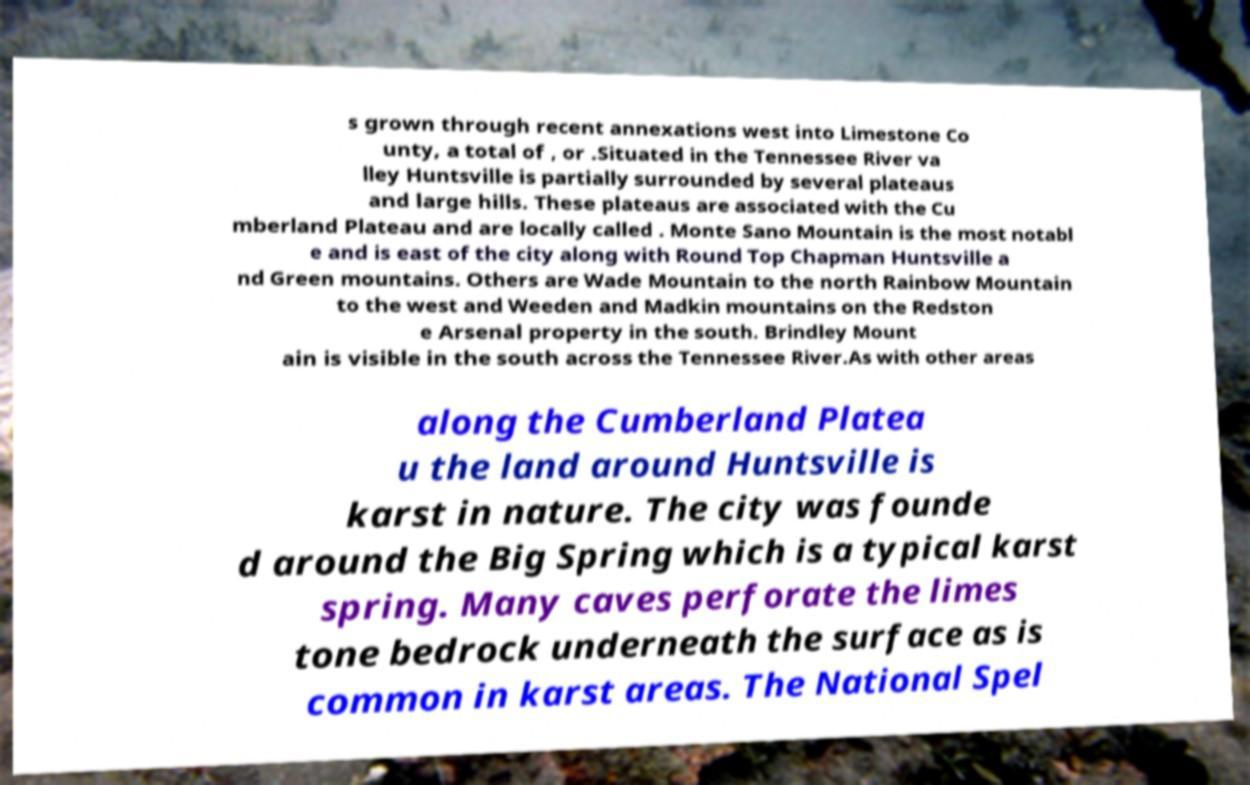Can you accurately transcribe the text from the provided image for me? s grown through recent annexations west into Limestone Co unty, a total of , or .Situated in the Tennessee River va lley Huntsville is partially surrounded by several plateaus and large hills. These plateaus are associated with the Cu mberland Plateau and are locally called . Monte Sano Mountain is the most notabl e and is east of the city along with Round Top Chapman Huntsville a nd Green mountains. Others are Wade Mountain to the north Rainbow Mountain to the west and Weeden and Madkin mountains on the Redston e Arsenal property in the south. Brindley Mount ain is visible in the south across the Tennessee River.As with other areas along the Cumberland Platea u the land around Huntsville is karst in nature. The city was founde d around the Big Spring which is a typical karst spring. Many caves perforate the limes tone bedrock underneath the surface as is common in karst areas. The National Spel 